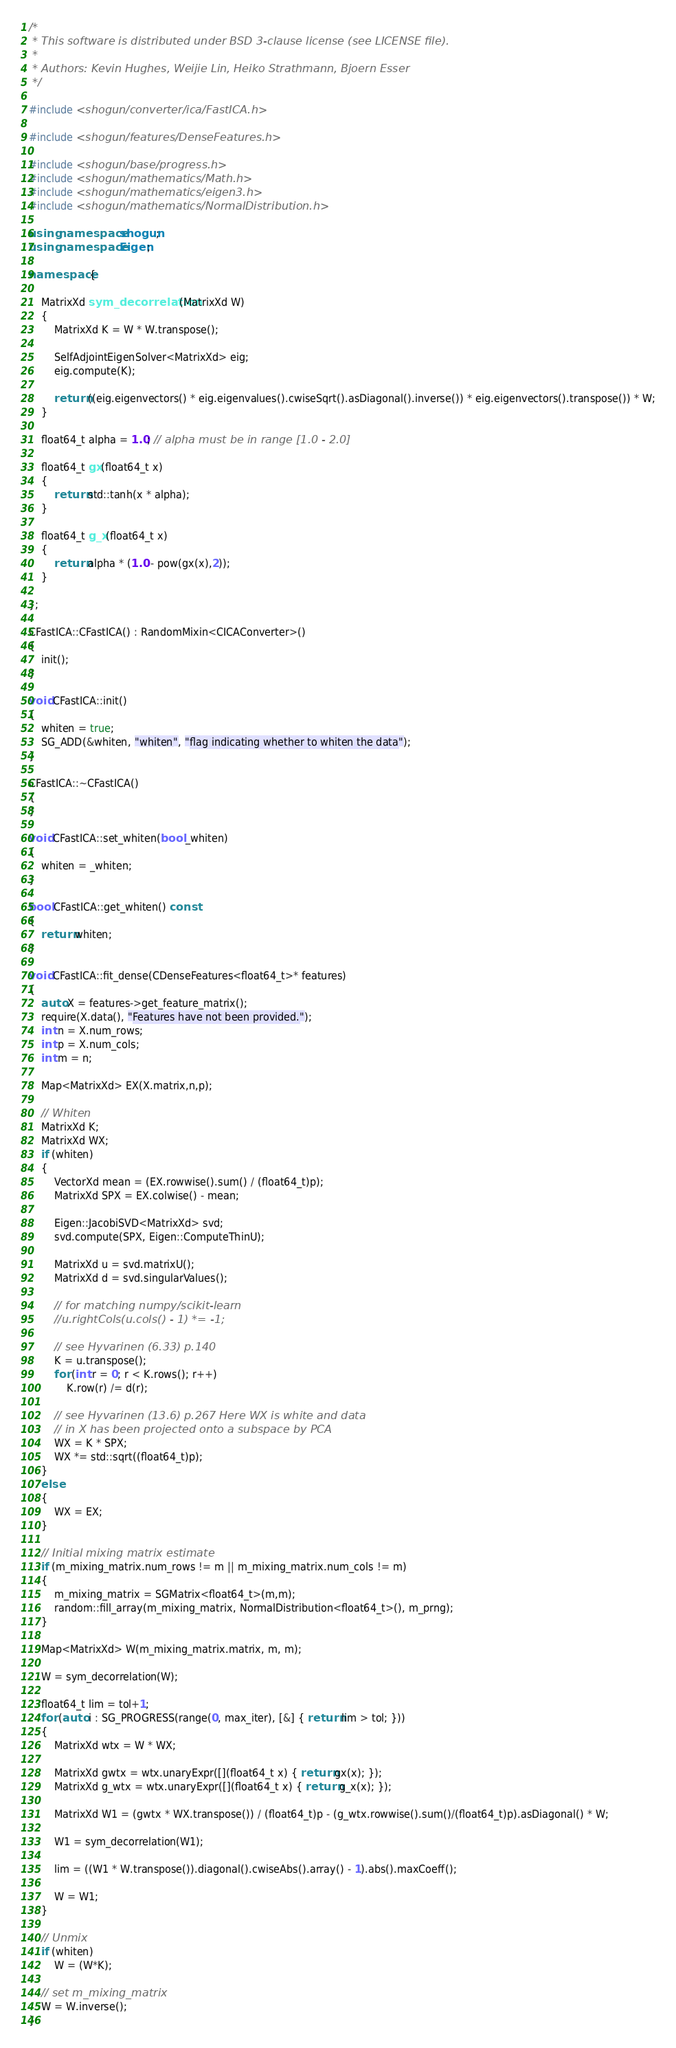Convert code to text. <code><loc_0><loc_0><loc_500><loc_500><_C++_>/*
 * This software is distributed under BSD 3-clause license (see LICENSE file).
 *
 * Authors: Kevin Hughes, Weijie Lin, Heiko Strathmann, Bjoern Esser
 */

#include <shogun/converter/ica/FastICA.h>

#include <shogun/features/DenseFeatures.h>

#include <shogun/base/progress.h>
#include <shogun/mathematics/Math.h>
#include <shogun/mathematics/eigen3.h>
#include <shogun/mathematics/NormalDistribution.h>

using namespace shogun;
using namespace Eigen;

namespace {

	MatrixXd sym_decorrelation(MatrixXd W)
	{
		MatrixXd K = W * W.transpose();

		SelfAdjointEigenSolver<MatrixXd> eig;
		eig.compute(K);

		return ((eig.eigenvectors() * eig.eigenvalues().cwiseSqrt().asDiagonal().inverse()) * eig.eigenvectors().transpose()) * W;
	}

	float64_t alpha = 1.0; // alpha must be in range [1.0 - 2.0]

	float64_t gx(float64_t x)
	{
		return std::tanh(x * alpha);
	}

	float64_t g_x(float64_t x)
	{
		return alpha * (1.0 - pow(gx(x),2));
	}

};

CFastICA::CFastICA() : RandomMixin<CICAConverter>()
{
	init();
}

void CFastICA::init()
{
	whiten = true;
	SG_ADD(&whiten, "whiten", "flag indicating whether to whiten the data");
}

CFastICA::~CFastICA()
{
}

void CFastICA::set_whiten(bool _whiten)
{
	whiten = _whiten;
}

bool CFastICA::get_whiten() const
{
	return whiten;
}

void CFastICA::fit_dense(CDenseFeatures<float64_t>* features)
{
	auto X = features->get_feature_matrix();
	require(X.data(), "Features have not been provided.");
	int n = X.num_rows;
	int p = X.num_cols;
	int m = n;

	Map<MatrixXd> EX(X.matrix,n,p);

	// Whiten
	MatrixXd K;
	MatrixXd WX;
	if (whiten)
	{
		VectorXd mean = (EX.rowwise().sum() / (float64_t)p);
		MatrixXd SPX = EX.colwise() - mean;

		Eigen::JacobiSVD<MatrixXd> svd;
		svd.compute(SPX, Eigen::ComputeThinU);

		MatrixXd u = svd.matrixU();
		MatrixXd d = svd.singularValues();

		// for matching numpy/scikit-learn
		//u.rightCols(u.cols() - 1) *= -1;

		// see Hyvarinen (6.33) p.140
		K = u.transpose();
		for (int r = 0; r < K.rows(); r++)
			K.row(r) /= d(r);

		// see Hyvarinen (13.6) p.267 Here WX is white and data
		// in X has been projected onto a subspace by PCA
		WX = K * SPX;
		WX *= std::sqrt((float64_t)p);
	}
	else
	{
		WX = EX;
	}

	// Initial mixing matrix estimate
	if (m_mixing_matrix.num_rows != m || m_mixing_matrix.num_cols != m)
	{
		m_mixing_matrix = SGMatrix<float64_t>(m,m);
		random::fill_array(m_mixing_matrix, NormalDistribution<float64_t>(), m_prng);
	}

	Map<MatrixXd> W(m_mixing_matrix.matrix, m, m);

	W = sym_decorrelation(W);

	float64_t lim = tol+1;
	for (auto i : SG_PROGRESS(range(0, max_iter), [&] { return lim > tol; }))
	{
		MatrixXd wtx = W * WX;

		MatrixXd gwtx = wtx.unaryExpr([](float64_t x) { return gx(x); });
		MatrixXd g_wtx = wtx.unaryExpr([](float64_t x) { return g_x(x); });

		MatrixXd W1 = (gwtx * WX.transpose()) / (float64_t)p - (g_wtx.rowwise().sum()/(float64_t)p).asDiagonal() * W;

		W1 = sym_decorrelation(W1);

		lim = ((W1 * W.transpose()).diagonal().cwiseAbs().array() - 1).abs().maxCoeff();

		W = W1;
	}

	// Unmix
	if (whiten)
		W = (W*K);

	// set m_mixing_matrix
	W = W.inverse();
}
</code> 